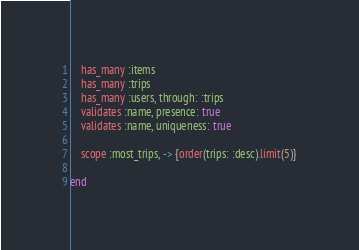<code> <loc_0><loc_0><loc_500><loc_500><_Ruby_>    has_many :items
    has_many :trips
    has_many :users, through: :trips
    validates :name, presence: true
    validates :name, uniqueness: true

    scope :most_trips, -> {order(trips: :desc).limit(5)}

end
</code> 